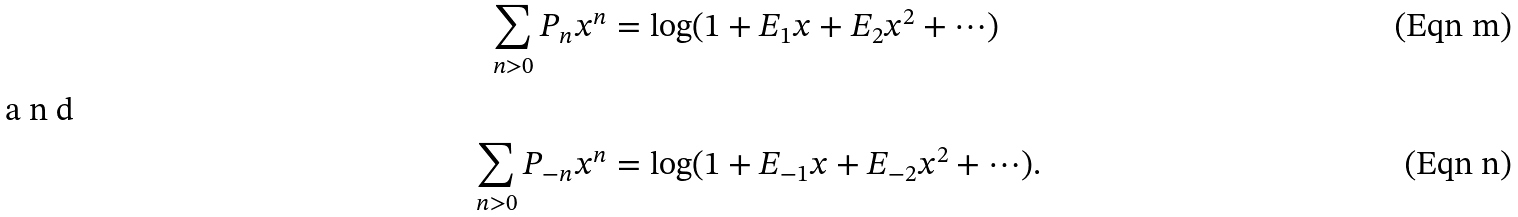Convert formula to latex. <formula><loc_0><loc_0><loc_500><loc_500>\sum _ { n > 0 } P _ { n } x ^ { n } & = \log ( 1 + E _ { 1 } x + E _ { 2 } x ^ { 2 } + \cdots ) \\ \intertext { a n d } \sum _ { n > 0 } P _ { - n } x ^ { n } & = \log ( 1 + E _ { - 1 } x + E _ { - 2 } x ^ { 2 } + \cdots ) .</formula> 